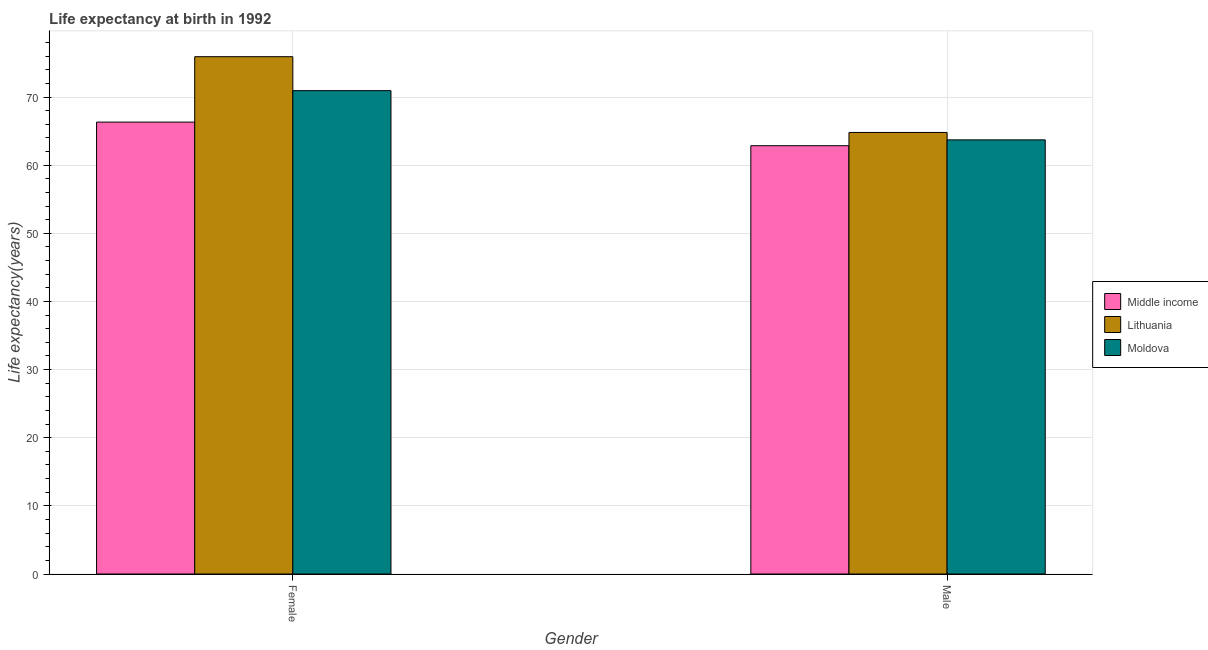How many different coloured bars are there?
Your answer should be compact. 3. How many groups of bars are there?
Your answer should be very brief. 2. Are the number of bars per tick equal to the number of legend labels?
Keep it short and to the point. Yes. What is the life expectancy(male) in Middle income?
Your answer should be compact. 62.86. Across all countries, what is the maximum life expectancy(female)?
Make the answer very short. 75.93. Across all countries, what is the minimum life expectancy(male)?
Provide a succinct answer. 62.86. In which country was the life expectancy(female) maximum?
Offer a very short reply. Lithuania. What is the total life expectancy(female) in the graph?
Your answer should be very brief. 213.2. What is the difference between the life expectancy(male) in Middle income and that in Moldova?
Your response must be concise. -0.86. What is the difference between the life expectancy(female) in Lithuania and the life expectancy(male) in Middle income?
Give a very brief answer. 13.07. What is the average life expectancy(male) per country?
Provide a succinct answer. 63.8. What is the difference between the life expectancy(female) and life expectancy(male) in Lithuania?
Your answer should be compact. 11.12. In how many countries, is the life expectancy(female) greater than 48 years?
Provide a short and direct response. 3. What is the ratio of the life expectancy(female) in Moldova to that in Lithuania?
Make the answer very short. 0.93. Is the life expectancy(female) in Moldova less than that in Lithuania?
Give a very brief answer. Yes. In how many countries, is the life expectancy(male) greater than the average life expectancy(male) taken over all countries?
Keep it short and to the point. 1. What does the 1st bar from the left in Female represents?
Provide a succinct answer. Middle income. What does the 1st bar from the right in Male represents?
Ensure brevity in your answer.  Moldova. How many bars are there?
Make the answer very short. 6. How many countries are there in the graph?
Your answer should be very brief. 3. Are the values on the major ticks of Y-axis written in scientific E-notation?
Provide a short and direct response. No. Does the graph contain any zero values?
Your response must be concise. No. Where does the legend appear in the graph?
Give a very brief answer. Center right. How many legend labels are there?
Ensure brevity in your answer.  3. How are the legend labels stacked?
Provide a short and direct response. Vertical. What is the title of the graph?
Your answer should be very brief. Life expectancy at birth in 1992. What is the label or title of the X-axis?
Your response must be concise. Gender. What is the label or title of the Y-axis?
Your response must be concise. Life expectancy(years). What is the Life expectancy(years) in Middle income in Female?
Give a very brief answer. 66.33. What is the Life expectancy(years) in Lithuania in Female?
Your response must be concise. 75.93. What is the Life expectancy(years) of Moldova in Female?
Offer a very short reply. 70.94. What is the Life expectancy(years) of Middle income in Male?
Your answer should be very brief. 62.86. What is the Life expectancy(years) of Lithuania in Male?
Your response must be concise. 64.81. What is the Life expectancy(years) in Moldova in Male?
Offer a very short reply. 63.72. Across all Gender, what is the maximum Life expectancy(years) in Middle income?
Give a very brief answer. 66.33. Across all Gender, what is the maximum Life expectancy(years) of Lithuania?
Offer a terse response. 75.93. Across all Gender, what is the maximum Life expectancy(years) of Moldova?
Your answer should be compact. 70.94. Across all Gender, what is the minimum Life expectancy(years) of Middle income?
Keep it short and to the point. 62.86. Across all Gender, what is the minimum Life expectancy(years) of Lithuania?
Your answer should be compact. 64.81. Across all Gender, what is the minimum Life expectancy(years) of Moldova?
Give a very brief answer. 63.72. What is the total Life expectancy(years) in Middle income in the graph?
Your response must be concise. 129.19. What is the total Life expectancy(years) in Lithuania in the graph?
Your answer should be compact. 140.74. What is the total Life expectancy(years) of Moldova in the graph?
Offer a very short reply. 134.67. What is the difference between the Life expectancy(years) in Middle income in Female and that in Male?
Provide a short and direct response. 3.46. What is the difference between the Life expectancy(years) of Lithuania in Female and that in Male?
Make the answer very short. 11.12. What is the difference between the Life expectancy(years) of Moldova in Female and that in Male?
Your answer should be very brief. 7.22. What is the difference between the Life expectancy(years) of Middle income in Female and the Life expectancy(years) of Lithuania in Male?
Your answer should be very brief. 1.52. What is the difference between the Life expectancy(years) in Middle income in Female and the Life expectancy(years) in Moldova in Male?
Provide a succinct answer. 2.61. What is the difference between the Life expectancy(years) of Lithuania in Female and the Life expectancy(years) of Moldova in Male?
Your response must be concise. 12.21. What is the average Life expectancy(years) of Middle income per Gender?
Your response must be concise. 64.6. What is the average Life expectancy(years) of Lithuania per Gender?
Provide a succinct answer. 70.37. What is the average Life expectancy(years) of Moldova per Gender?
Offer a very short reply. 67.33. What is the difference between the Life expectancy(years) in Middle income and Life expectancy(years) in Lithuania in Female?
Provide a succinct answer. -9.6. What is the difference between the Life expectancy(years) of Middle income and Life expectancy(years) of Moldova in Female?
Offer a terse response. -4.62. What is the difference between the Life expectancy(years) of Lithuania and Life expectancy(years) of Moldova in Female?
Provide a succinct answer. 4.99. What is the difference between the Life expectancy(years) in Middle income and Life expectancy(years) in Lithuania in Male?
Make the answer very short. -1.95. What is the difference between the Life expectancy(years) of Middle income and Life expectancy(years) of Moldova in Male?
Give a very brief answer. -0.86. What is the difference between the Life expectancy(years) in Lithuania and Life expectancy(years) in Moldova in Male?
Offer a terse response. 1.09. What is the ratio of the Life expectancy(years) in Middle income in Female to that in Male?
Ensure brevity in your answer.  1.06. What is the ratio of the Life expectancy(years) in Lithuania in Female to that in Male?
Ensure brevity in your answer.  1.17. What is the ratio of the Life expectancy(years) of Moldova in Female to that in Male?
Your answer should be very brief. 1.11. What is the difference between the highest and the second highest Life expectancy(years) of Middle income?
Provide a short and direct response. 3.46. What is the difference between the highest and the second highest Life expectancy(years) in Lithuania?
Your answer should be compact. 11.12. What is the difference between the highest and the second highest Life expectancy(years) in Moldova?
Offer a terse response. 7.22. What is the difference between the highest and the lowest Life expectancy(years) in Middle income?
Provide a short and direct response. 3.46. What is the difference between the highest and the lowest Life expectancy(years) of Lithuania?
Keep it short and to the point. 11.12. What is the difference between the highest and the lowest Life expectancy(years) of Moldova?
Your answer should be very brief. 7.22. 